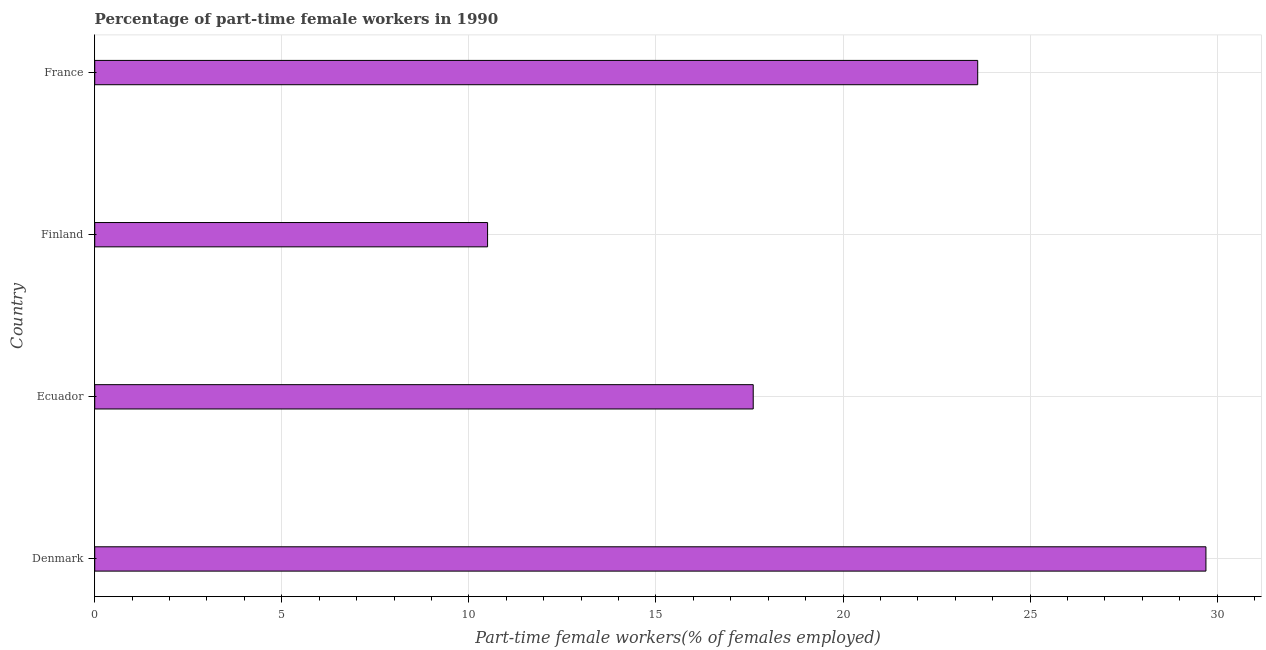Does the graph contain any zero values?
Provide a succinct answer. No. Does the graph contain grids?
Provide a succinct answer. Yes. What is the title of the graph?
Make the answer very short. Percentage of part-time female workers in 1990. What is the label or title of the X-axis?
Your answer should be very brief. Part-time female workers(% of females employed). What is the label or title of the Y-axis?
Provide a succinct answer. Country. What is the percentage of part-time female workers in Denmark?
Keep it short and to the point. 29.7. Across all countries, what is the maximum percentage of part-time female workers?
Your answer should be very brief. 29.7. In which country was the percentage of part-time female workers maximum?
Your answer should be compact. Denmark. What is the sum of the percentage of part-time female workers?
Provide a succinct answer. 81.4. What is the average percentage of part-time female workers per country?
Provide a short and direct response. 20.35. What is the median percentage of part-time female workers?
Make the answer very short. 20.6. What is the ratio of the percentage of part-time female workers in Ecuador to that in Finland?
Offer a very short reply. 1.68. Is the difference between the percentage of part-time female workers in Ecuador and Finland greater than the difference between any two countries?
Provide a succinct answer. No. What is the difference between the highest and the second highest percentage of part-time female workers?
Make the answer very short. 6.1. What is the difference between the highest and the lowest percentage of part-time female workers?
Offer a terse response. 19.2. How many bars are there?
Make the answer very short. 4. What is the difference between two consecutive major ticks on the X-axis?
Give a very brief answer. 5. Are the values on the major ticks of X-axis written in scientific E-notation?
Your response must be concise. No. What is the Part-time female workers(% of females employed) in Denmark?
Make the answer very short. 29.7. What is the Part-time female workers(% of females employed) of Ecuador?
Your answer should be compact. 17.6. What is the Part-time female workers(% of females employed) of France?
Offer a very short reply. 23.6. What is the difference between the Part-time female workers(% of females employed) in Ecuador and Finland?
Provide a succinct answer. 7.1. What is the difference between the Part-time female workers(% of females employed) in Ecuador and France?
Offer a very short reply. -6. What is the difference between the Part-time female workers(% of females employed) in Finland and France?
Ensure brevity in your answer.  -13.1. What is the ratio of the Part-time female workers(% of females employed) in Denmark to that in Ecuador?
Make the answer very short. 1.69. What is the ratio of the Part-time female workers(% of females employed) in Denmark to that in Finland?
Offer a terse response. 2.83. What is the ratio of the Part-time female workers(% of females employed) in Denmark to that in France?
Offer a terse response. 1.26. What is the ratio of the Part-time female workers(% of females employed) in Ecuador to that in Finland?
Give a very brief answer. 1.68. What is the ratio of the Part-time female workers(% of females employed) in Ecuador to that in France?
Give a very brief answer. 0.75. What is the ratio of the Part-time female workers(% of females employed) in Finland to that in France?
Make the answer very short. 0.45. 